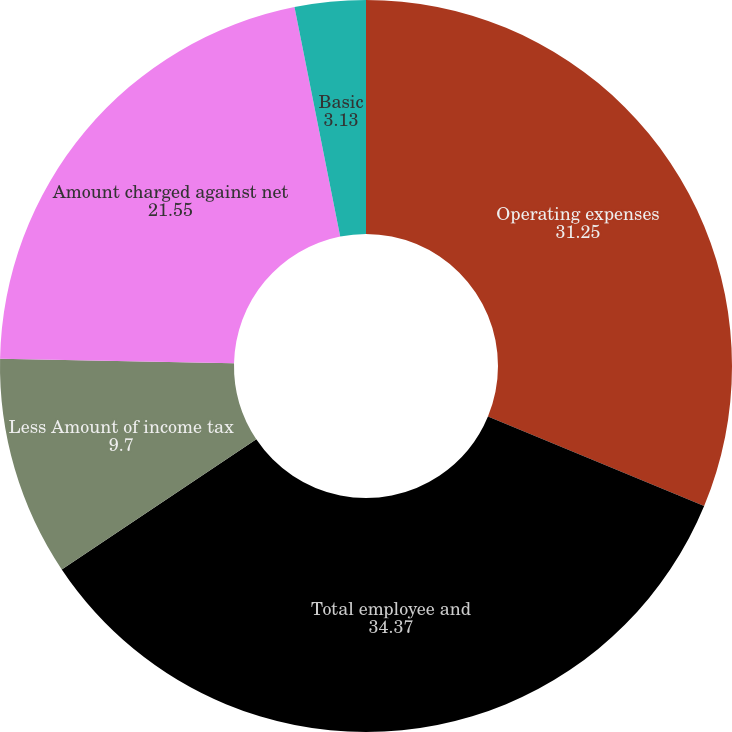Convert chart. <chart><loc_0><loc_0><loc_500><loc_500><pie_chart><fcel>Operating expenses<fcel>Total employee and<fcel>Less Amount of income tax<fcel>Amount charged against net<fcel>Basic<fcel>Diluted<nl><fcel>31.25%<fcel>34.37%<fcel>9.7%<fcel>21.55%<fcel>3.13%<fcel>0.0%<nl></chart> 